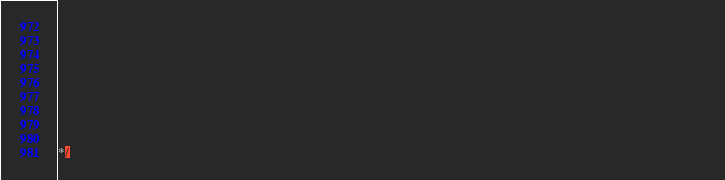<code> <loc_0><loc_0><loc_500><loc_500><_JavaScript_>                                                                                                                                                                                                       
                                                                                                                                                                                                       
                                                                                                                                                                                                       
                                                                                                                                                                                                       
                                                                                                                                                                                                       
                                                                                                                                                                                                       
                                                                                                                                                                                                       
                                                                                                                                                                                                       

*/</code> 